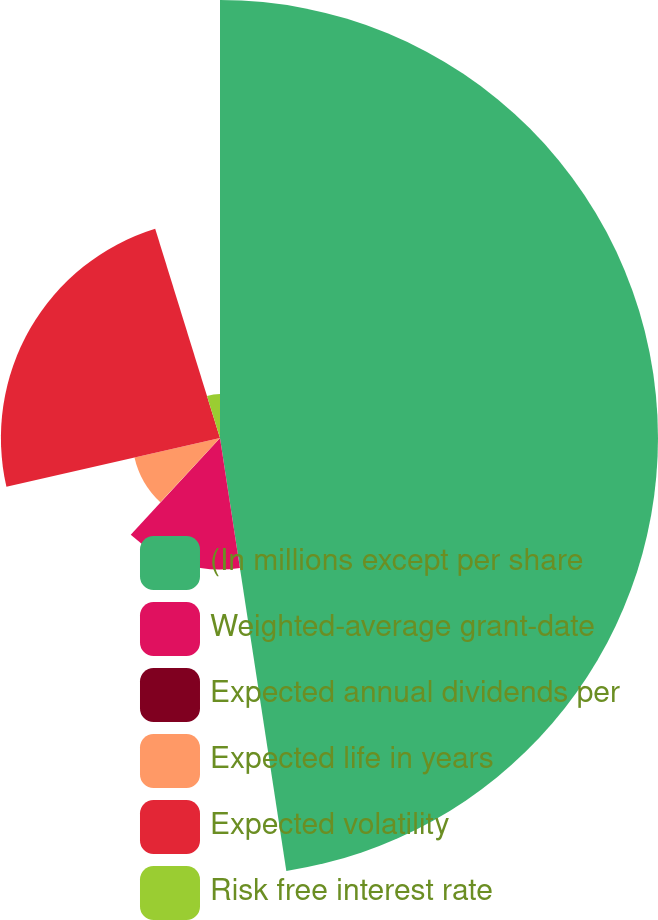Convert chart to OTSL. <chart><loc_0><loc_0><loc_500><loc_500><pie_chart><fcel>(In millions except per share<fcel>Weighted-average grant-date<fcel>Expected annual dividends per<fcel>Expected life in years<fcel>Expected volatility<fcel>Risk free interest rate<nl><fcel>47.58%<fcel>14.29%<fcel>0.02%<fcel>9.53%<fcel>23.8%<fcel>4.78%<nl></chart> 